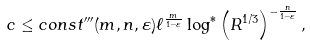Convert formula to latex. <formula><loc_0><loc_0><loc_500><loc_500>c \leq c o n s t ^ { \prime \prime \prime } ( m , n , \varepsilon ) \ell ^ { \frac { m } { 1 - \varepsilon } } \log ^ { * } \left ( R ^ { 1 / 3 } \right ) ^ { - \frac { n } { 1 - \varepsilon } } ,</formula> 